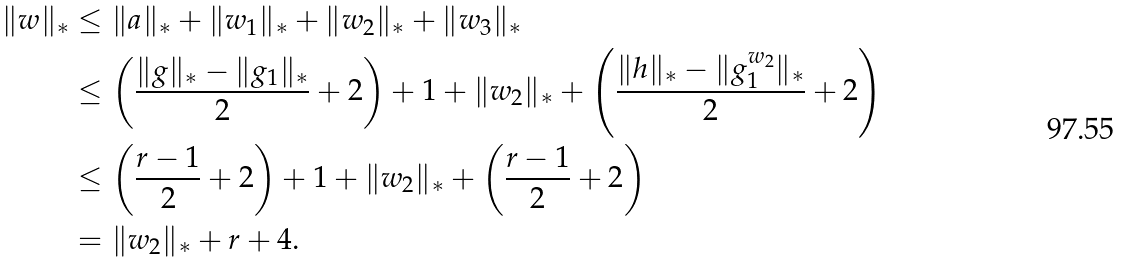Convert formula to latex. <formula><loc_0><loc_0><loc_500><loc_500>\| w \| _ { * } & \leq \| a \| _ { * } + \| w _ { 1 } \| _ { * } + \| w _ { 2 } \| _ { * } + \| w _ { 3 } \| _ { * } \\ & \leq \left ( \frac { \| g \| _ { * } - \| g _ { 1 } \| _ { * } } 2 + 2 \right ) + 1 + \| w _ { 2 } \| _ { * } + \left ( \frac { \| h \| _ { * } - \| g _ { 1 } ^ { w _ { 2 } } \| _ { * } } 2 + 2 \right ) \\ & \leq \left ( \frac { r - 1 } 2 + 2 \right ) + 1 + \| w _ { 2 } \| _ { * } + \left ( \frac { r - 1 } 2 + 2 \right ) \\ & = \| w _ { 2 } \| _ { * } + r + 4 .</formula> 